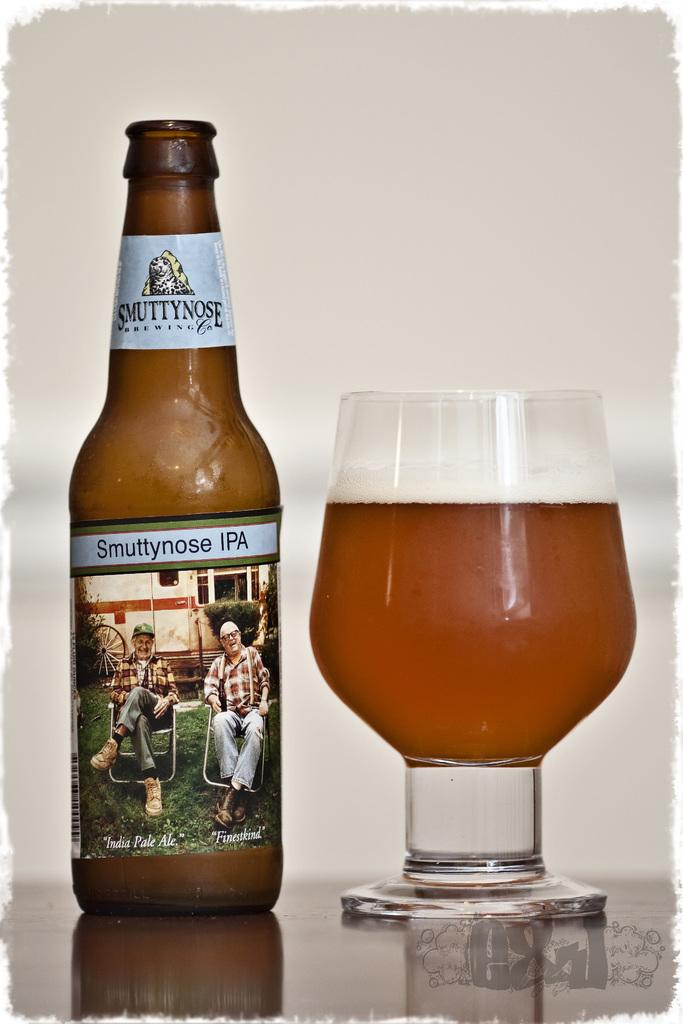Provide a one-sentence caption for the provided image. A bottle of Smuttynose IPA beer with the beer poured into a chalice. 